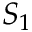Convert formula to latex. <formula><loc_0><loc_0><loc_500><loc_500>S _ { 1 }</formula> 